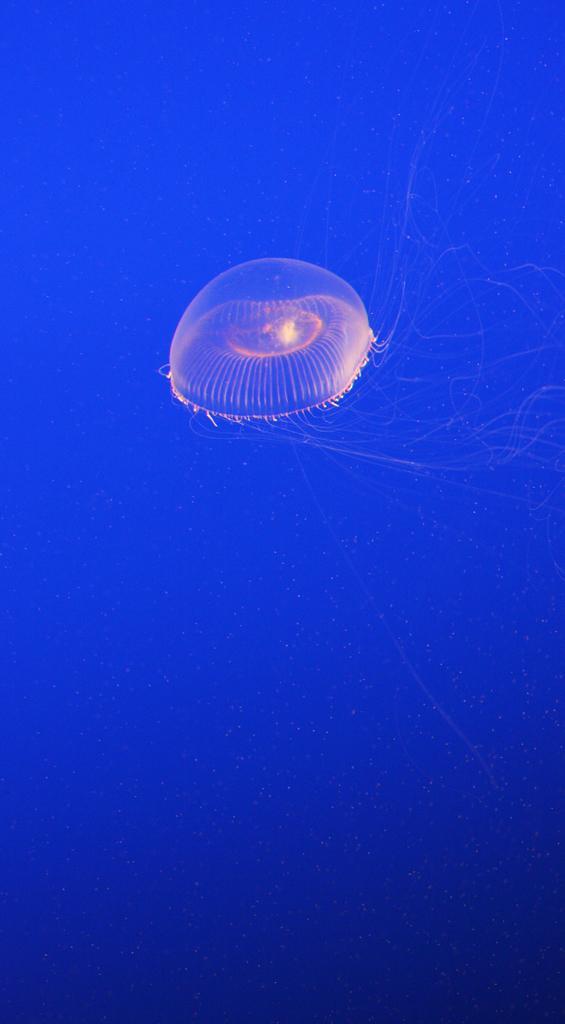Describe this image in one or two sentences. This picture shows a jellyfish and we see blue color background. 